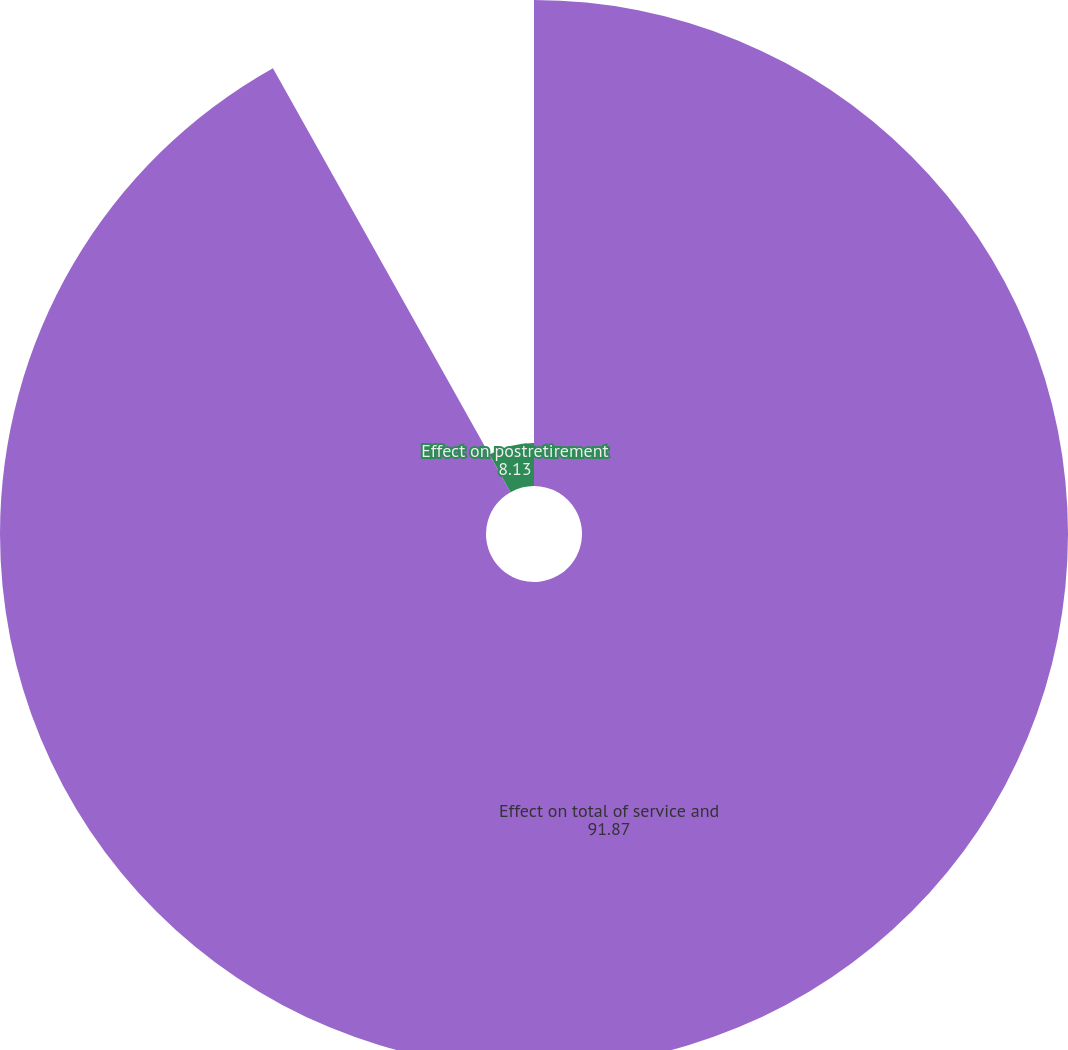<chart> <loc_0><loc_0><loc_500><loc_500><pie_chart><fcel>Effect on total of service and<fcel>Effect on postretirement<nl><fcel>91.87%<fcel>8.13%<nl></chart> 